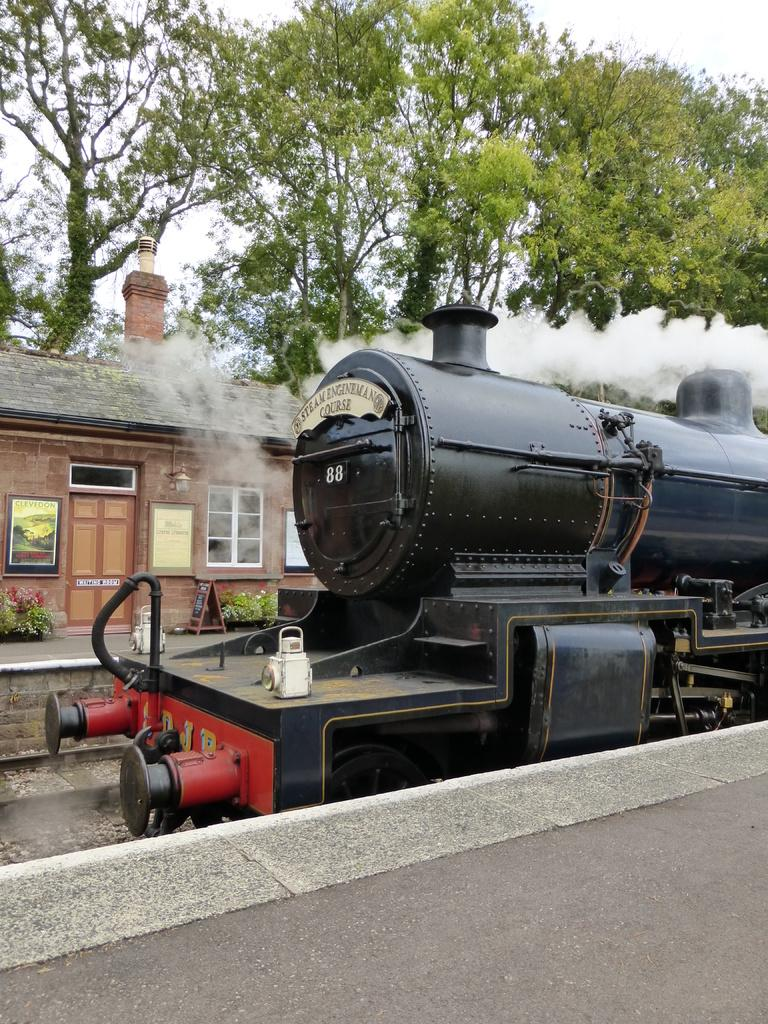What is the main subject of the image? The main subject of the image is a train. What can be seen in the background of the image? There is a railway track, a house, trees, and the sky visible in the image. Can you describe the house in the image? The house has a door and photo frames inside. What is the train's position in relation to the other elements in the image? The train is on the railway track, which is near the house and trees. Can you tell me how many bubbles are floating around the train in the image? There are no bubbles present in the image; it features a train, railway track, house, trees, and the sky. What type of wave is visible in the image? There is no wave present in the image; it features a train, railway track, house, trees, and the sky. 